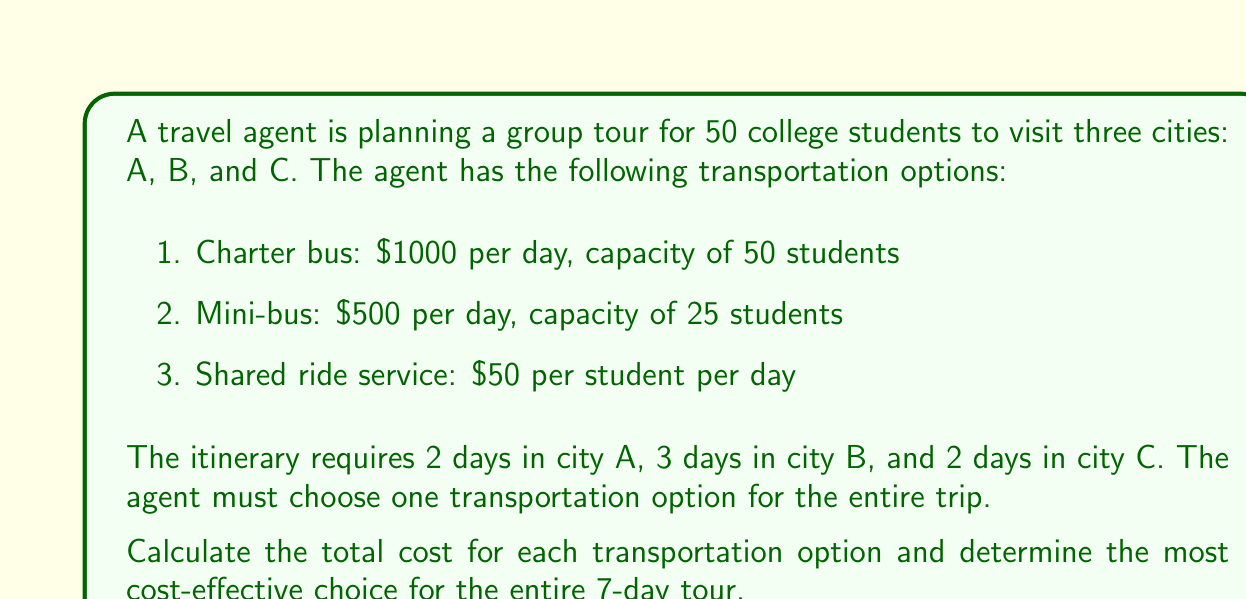Provide a solution to this math problem. Let's calculate the total cost for each transportation option:

1. Charter bus:
   - Cost per day: $1000
   - Number of days: 7
   - Total cost: $1000 * 7 = $7000

2. Mini-bus:
   - Cost per day: $500
   - Number of buses needed: 2 (since capacity is 25 and we have 50 students)
   - Number of days: 7
   - Total cost: $500 * 2 * 7 = $7000

3. Shared ride service:
   - Cost per student per day: $50
   - Number of students: 50
   - Number of days: 7
   - Total cost: $50 * 50 * 7 = $17,500

To determine the most cost-effective option, we compare the total costs:

$$\begin{align*}
\text{Charter bus} &: \$7000 \\
\text{Mini-bus} &: \$7000 \\
\text{Shared ride service} &: \$17,500
\end{align*}$$

The charter bus and mini-bus options have the same total cost, which is significantly lower than the shared ride service option.
Answer: The most cost-effective transportation options are the charter bus and mini-bus, both costing $7000 for the entire 7-day tour. 